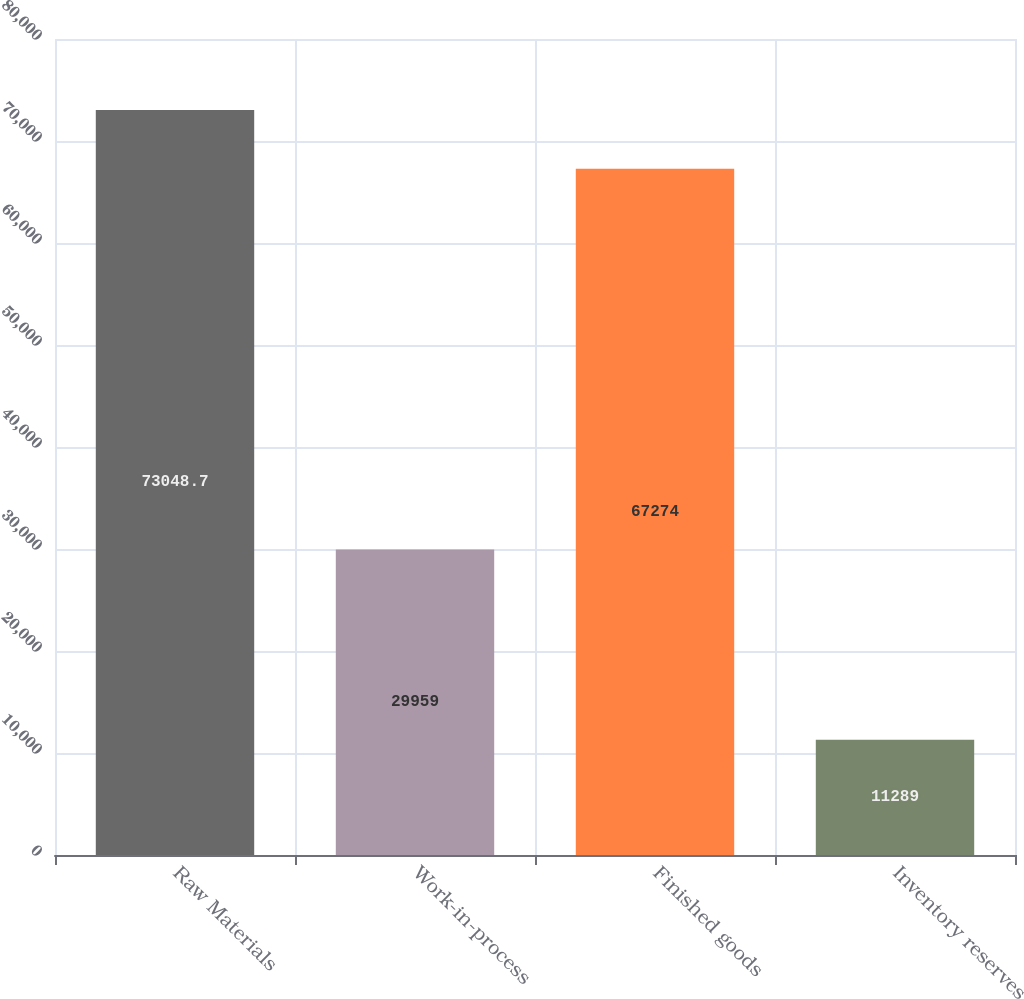<chart> <loc_0><loc_0><loc_500><loc_500><bar_chart><fcel>Raw Materials<fcel>Work-in-process<fcel>Finished goods<fcel>Inventory reserves<nl><fcel>73048.7<fcel>29959<fcel>67274<fcel>11289<nl></chart> 